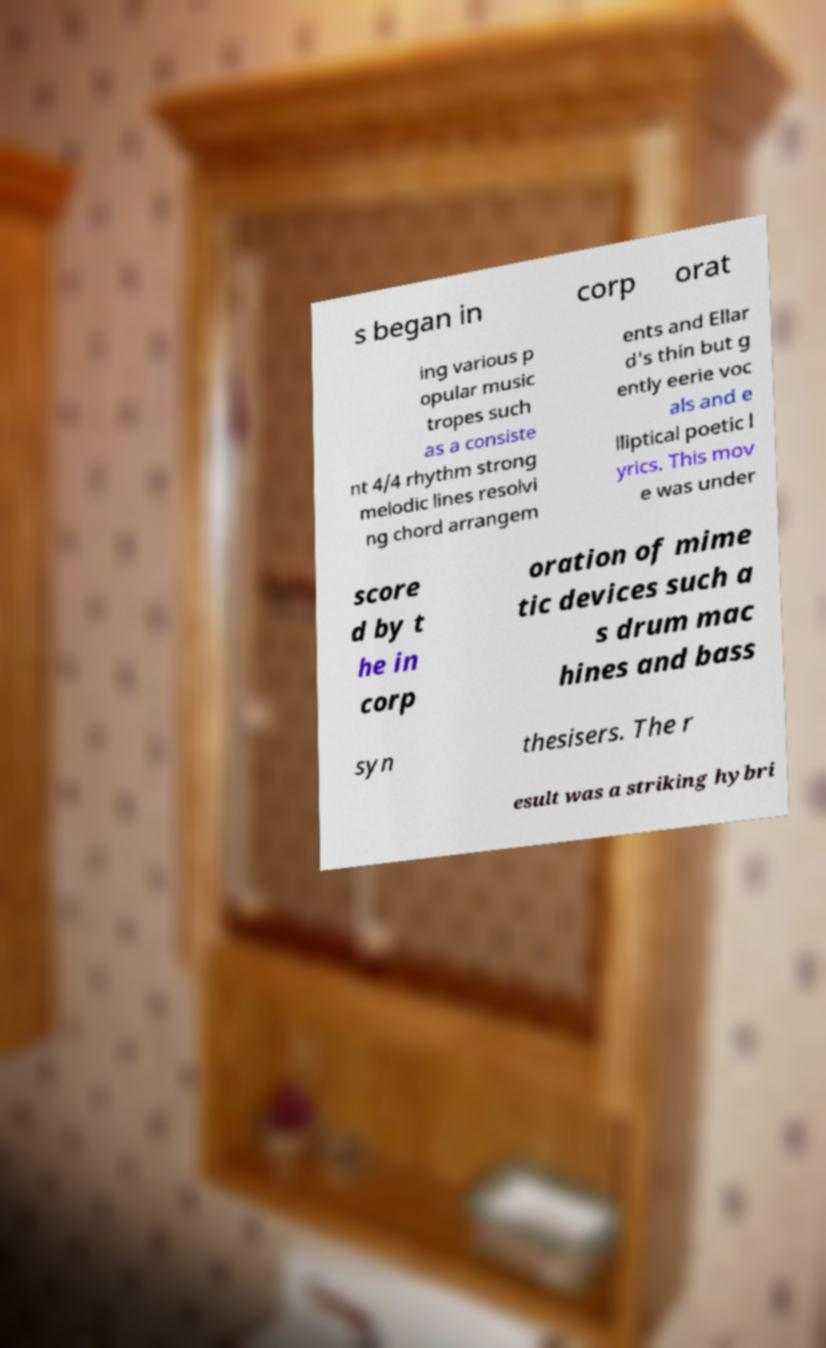For documentation purposes, I need the text within this image transcribed. Could you provide that? s began in corp orat ing various p opular music tropes such as a consiste nt 4/4 rhythm strong melodic lines resolvi ng chord arrangem ents and Ellar d's thin but g ently eerie voc als and e lliptical poetic l yrics. This mov e was under score d by t he in corp oration of mime tic devices such a s drum mac hines and bass syn thesisers. The r esult was a striking hybri 